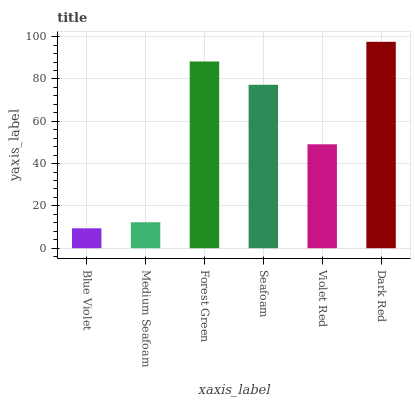Is Medium Seafoam the minimum?
Answer yes or no. No. Is Medium Seafoam the maximum?
Answer yes or no. No. Is Medium Seafoam greater than Blue Violet?
Answer yes or no. Yes. Is Blue Violet less than Medium Seafoam?
Answer yes or no. Yes. Is Blue Violet greater than Medium Seafoam?
Answer yes or no. No. Is Medium Seafoam less than Blue Violet?
Answer yes or no. No. Is Seafoam the high median?
Answer yes or no. Yes. Is Violet Red the low median?
Answer yes or no. Yes. Is Medium Seafoam the high median?
Answer yes or no. No. Is Medium Seafoam the low median?
Answer yes or no. No. 